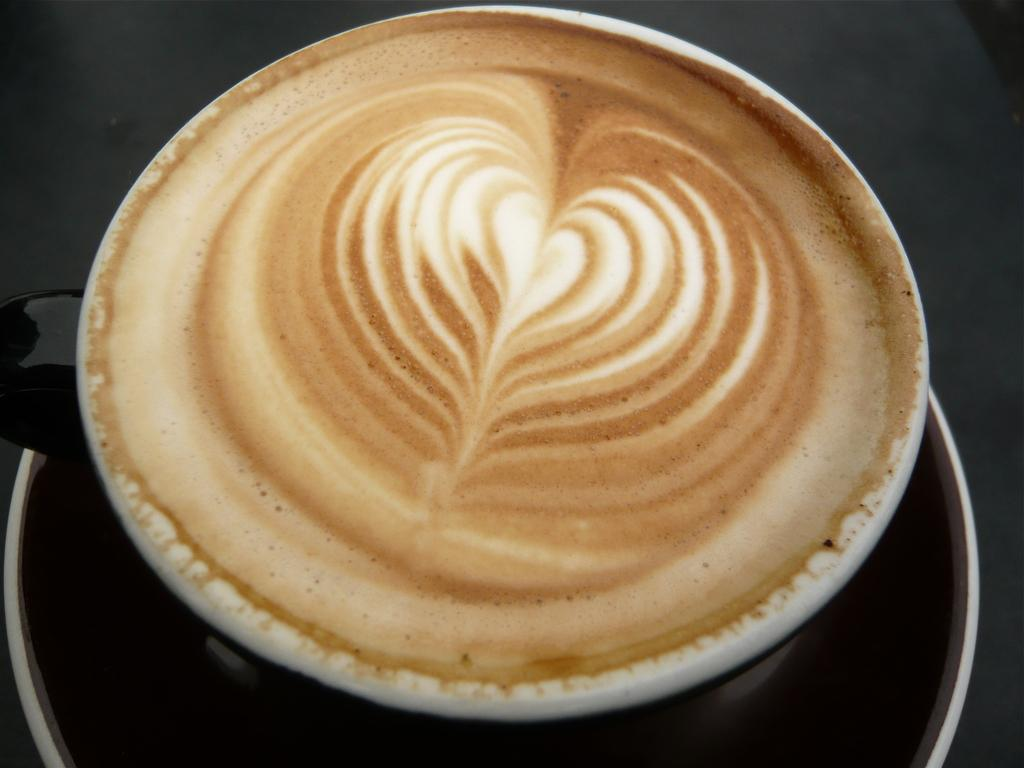What is present in the image related to coffee? There is a coffee cup in the image. Is there anything accompanying the coffee cup? Yes, the coffee cup has a saucer. Where is the oven located in the image? There is no oven present in the image. Can you see any snakes in the image? There are no snakes present in the image. 